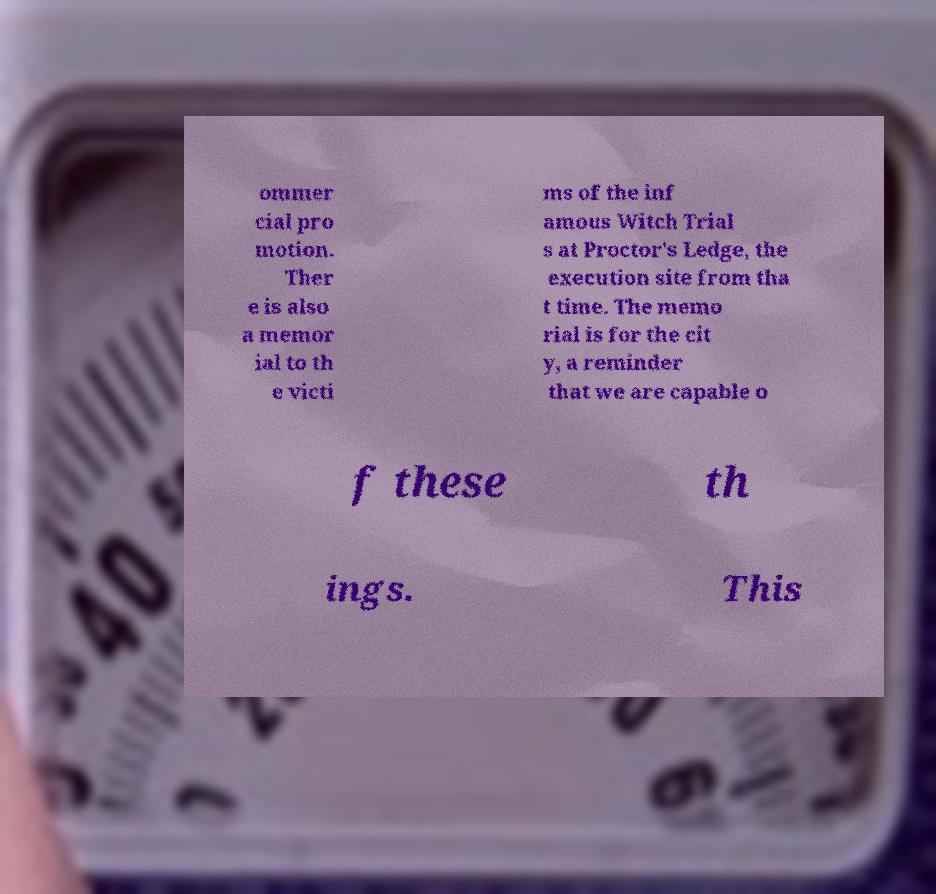Can you accurately transcribe the text from the provided image for me? ommer cial pro motion. Ther e is also a memor ial to th e victi ms of the inf amous Witch Trial s at Proctor's Ledge, the execution site from tha t time. The memo rial is for the cit y, a reminder that we are capable o f these th ings. This 